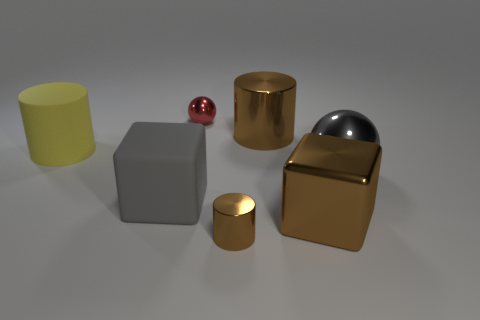What materials do the objects in the image appear to be made of? The objects in the image appear to be made of different materials. The cylindrical objects have a metallic sheen, suggesting a possible metal or alloy, while the cube and the rectangular block seem to have matte surfaces, possibly made of plastic or painted in a way that doesn't reflect light much. 